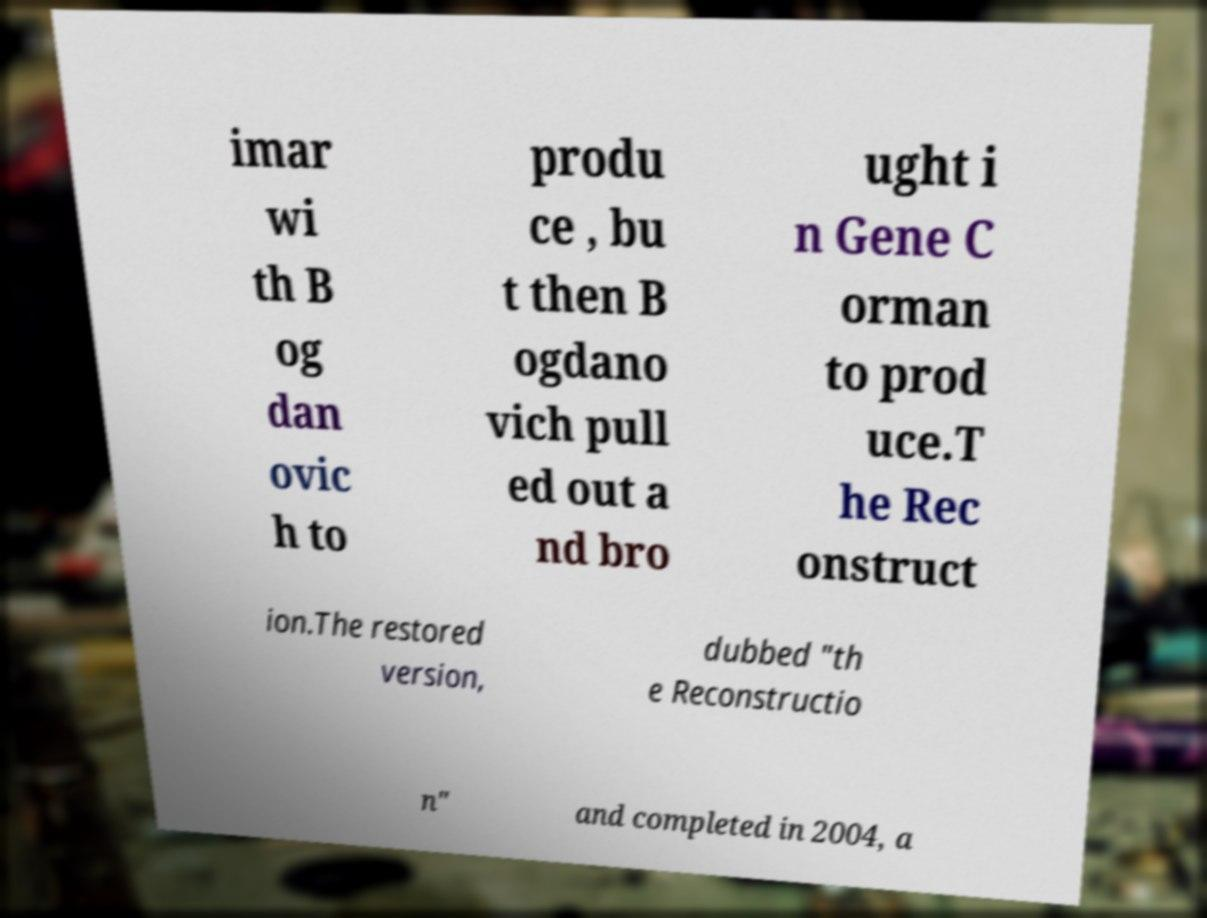Please read and relay the text visible in this image. What does it say? imar wi th B og dan ovic h to produ ce , bu t then B ogdano vich pull ed out a nd bro ught i n Gene C orman to prod uce.T he Rec onstruct ion.The restored version, dubbed "th e Reconstructio n" and completed in 2004, a 